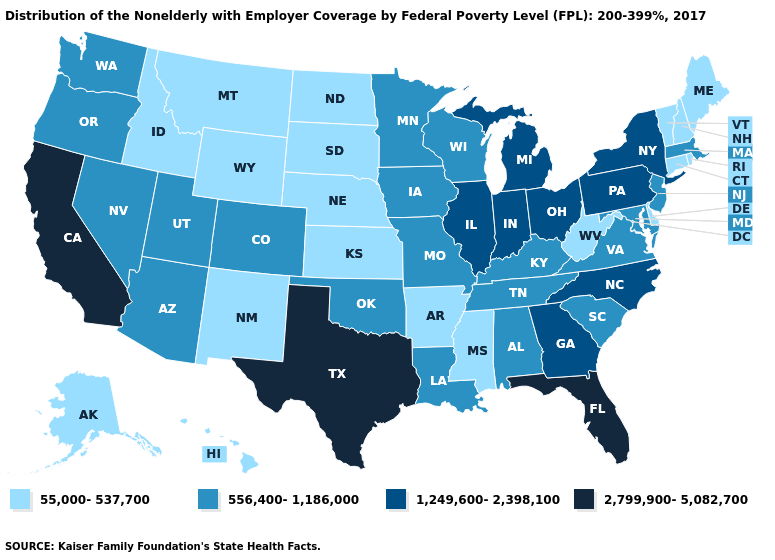Name the states that have a value in the range 556,400-1,186,000?
Concise answer only. Alabama, Arizona, Colorado, Iowa, Kentucky, Louisiana, Maryland, Massachusetts, Minnesota, Missouri, Nevada, New Jersey, Oklahoma, Oregon, South Carolina, Tennessee, Utah, Virginia, Washington, Wisconsin. Which states have the highest value in the USA?
Concise answer only. California, Florida, Texas. Name the states that have a value in the range 2,799,900-5,082,700?
Write a very short answer. California, Florida, Texas. Does Pennsylvania have the lowest value in the Northeast?
Quick response, please. No. Does Michigan have the highest value in the MidWest?
Answer briefly. Yes. Among the states that border Louisiana , which have the highest value?
Quick response, please. Texas. What is the value of California?
Write a very short answer. 2,799,900-5,082,700. What is the highest value in the USA?
Be succinct. 2,799,900-5,082,700. What is the value of New Hampshire?
Quick response, please. 55,000-537,700. Name the states that have a value in the range 1,249,600-2,398,100?
Give a very brief answer. Georgia, Illinois, Indiana, Michigan, New York, North Carolina, Ohio, Pennsylvania. Which states have the lowest value in the USA?
Give a very brief answer. Alaska, Arkansas, Connecticut, Delaware, Hawaii, Idaho, Kansas, Maine, Mississippi, Montana, Nebraska, New Hampshire, New Mexico, North Dakota, Rhode Island, South Dakota, Vermont, West Virginia, Wyoming. What is the highest value in the West ?
Write a very short answer. 2,799,900-5,082,700. Does South Dakota have the lowest value in the MidWest?
Concise answer only. Yes. Name the states that have a value in the range 55,000-537,700?
Quick response, please. Alaska, Arkansas, Connecticut, Delaware, Hawaii, Idaho, Kansas, Maine, Mississippi, Montana, Nebraska, New Hampshire, New Mexico, North Dakota, Rhode Island, South Dakota, Vermont, West Virginia, Wyoming. What is the lowest value in states that border South Carolina?
Short answer required. 1,249,600-2,398,100. 